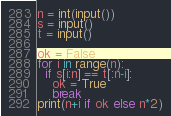<code> <loc_0><loc_0><loc_500><loc_500><_Python_>n = int(input())
s = input()
t = input()

ok = False
for i in range(n):
  if s[i:n] == t[:n-i]:
    ok = True
    break
print(n+i if ok else n*2)</code> 